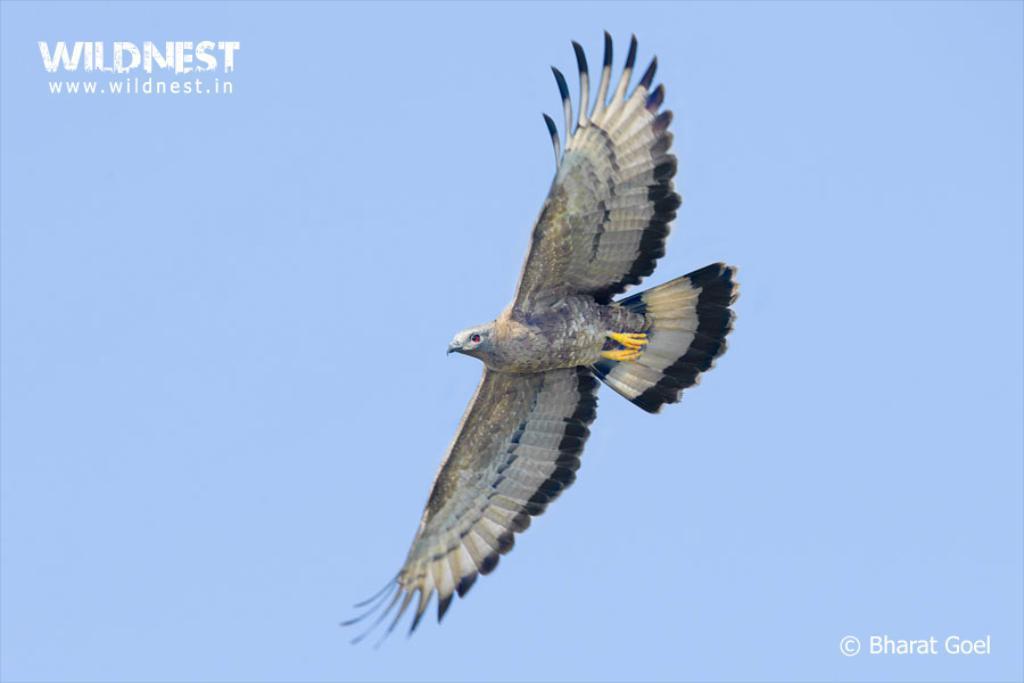Describe this image in one or two sentences. In this image, we can see a bird is flying in the air. Background we can see the sky. On the left side top corner and right side bottom corner of the image, we can see a watermark in the image. 